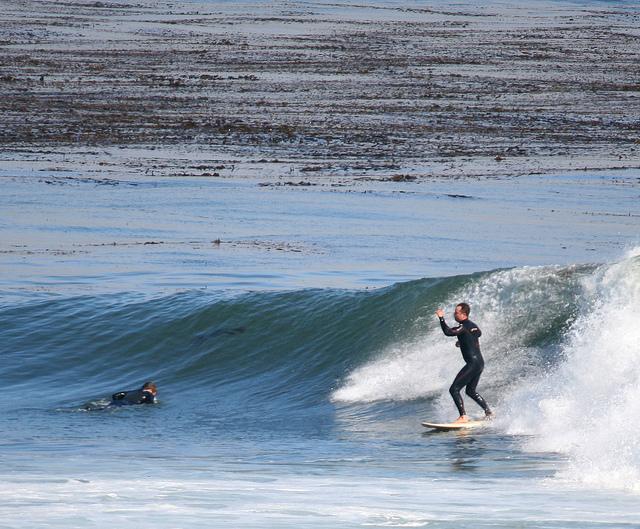What size is the wave?
Give a very brief answer. Medium. Is one of the surfers in danger?
Short answer required. No. What is the person on the left doing?
Be succinct. Swimming. Are both people standing up?
Answer briefly. No. 